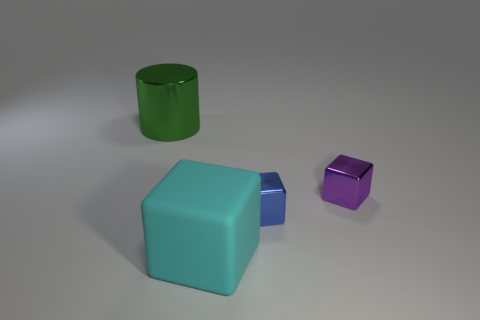Do the objects appear to be arranged in any particular pattern? The objects seem to be randomly arranged without a discernible pattern, spaced out on a flat surface. 